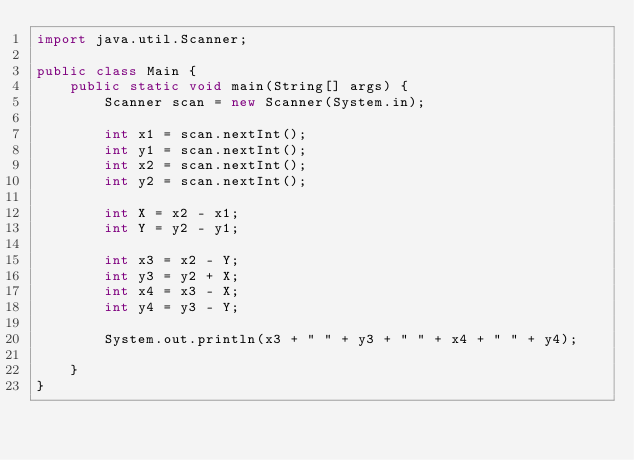Convert code to text. <code><loc_0><loc_0><loc_500><loc_500><_Java_>import java.util.Scanner;

public class Main {
	public static void main(String[] args) {
		Scanner scan = new Scanner(System.in);
		
		int x1 = scan.nextInt();
		int y1 = scan.nextInt();
		int x2 = scan.nextInt();
		int y2 = scan.nextInt();
		
		int X = x2 - x1;
		int Y = y2 - y1;
		
		int x3 = x2 - Y;
		int y3 = y2 + X;
		int x4 = x3 - X;
		int y4 = y3 - Y;
		
		System.out.println(x3 + " " + y3 + " " + x4 + " " + y4);
		
	}
}
</code> 